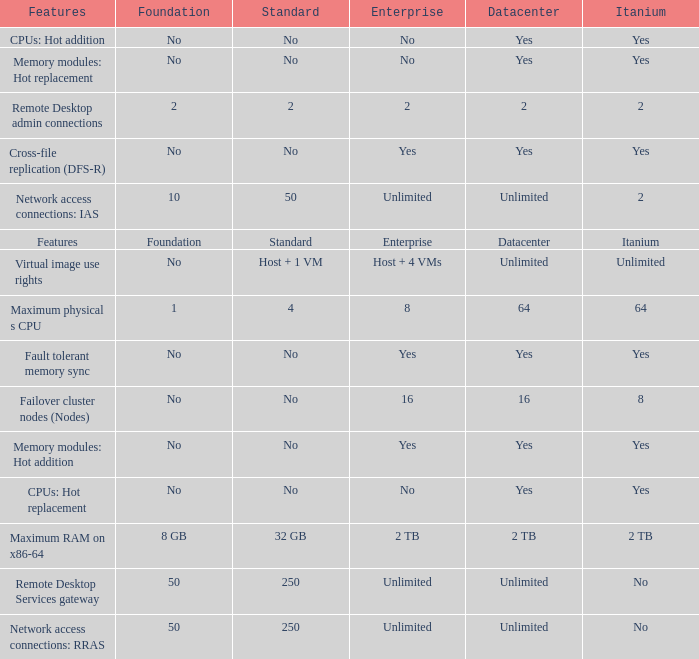What is the Datacenter for the Fault Tolerant Memory Sync Feature that has Yes for Itanium and No for Standard? Yes. Parse the table in full. {'header': ['Features', 'Foundation', 'Standard', 'Enterprise', 'Datacenter', 'Itanium'], 'rows': [['CPUs: Hot addition', 'No', 'No', 'No', 'Yes', 'Yes'], ['Memory modules: Hot replacement', 'No', 'No', 'No', 'Yes', 'Yes'], ['Remote Desktop admin connections', '2', '2', '2', '2', '2'], ['Cross-file replication (DFS-R)', 'No', 'No', 'Yes', 'Yes', 'Yes'], ['Network access connections: IAS', '10', '50', 'Unlimited', 'Unlimited', '2'], ['Features', 'Foundation', 'Standard', 'Enterprise', 'Datacenter', 'Itanium'], ['Virtual image use rights', 'No', 'Host + 1 VM', 'Host + 4 VMs', 'Unlimited', 'Unlimited'], ['Maximum physical s CPU', '1', '4', '8', '64', '64'], ['Fault tolerant memory sync', 'No', 'No', 'Yes', 'Yes', 'Yes'], ['Failover cluster nodes (Nodes)', 'No', 'No', '16', '16', '8'], ['Memory modules: Hot addition', 'No', 'No', 'Yes', 'Yes', 'Yes'], ['CPUs: Hot replacement', 'No', 'No', 'No', 'Yes', 'Yes'], ['Maximum RAM on x86-64', '8 GB', '32 GB', '2 TB', '2 TB', '2 TB'], ['Remote Desktop Services gateway', '50', '250', 'Unlimited', 'Unlimited', 'No'], ['Network access connections: RRAS', '50', '250', 'Unlimited', 'Unlimited', 'No']]} 